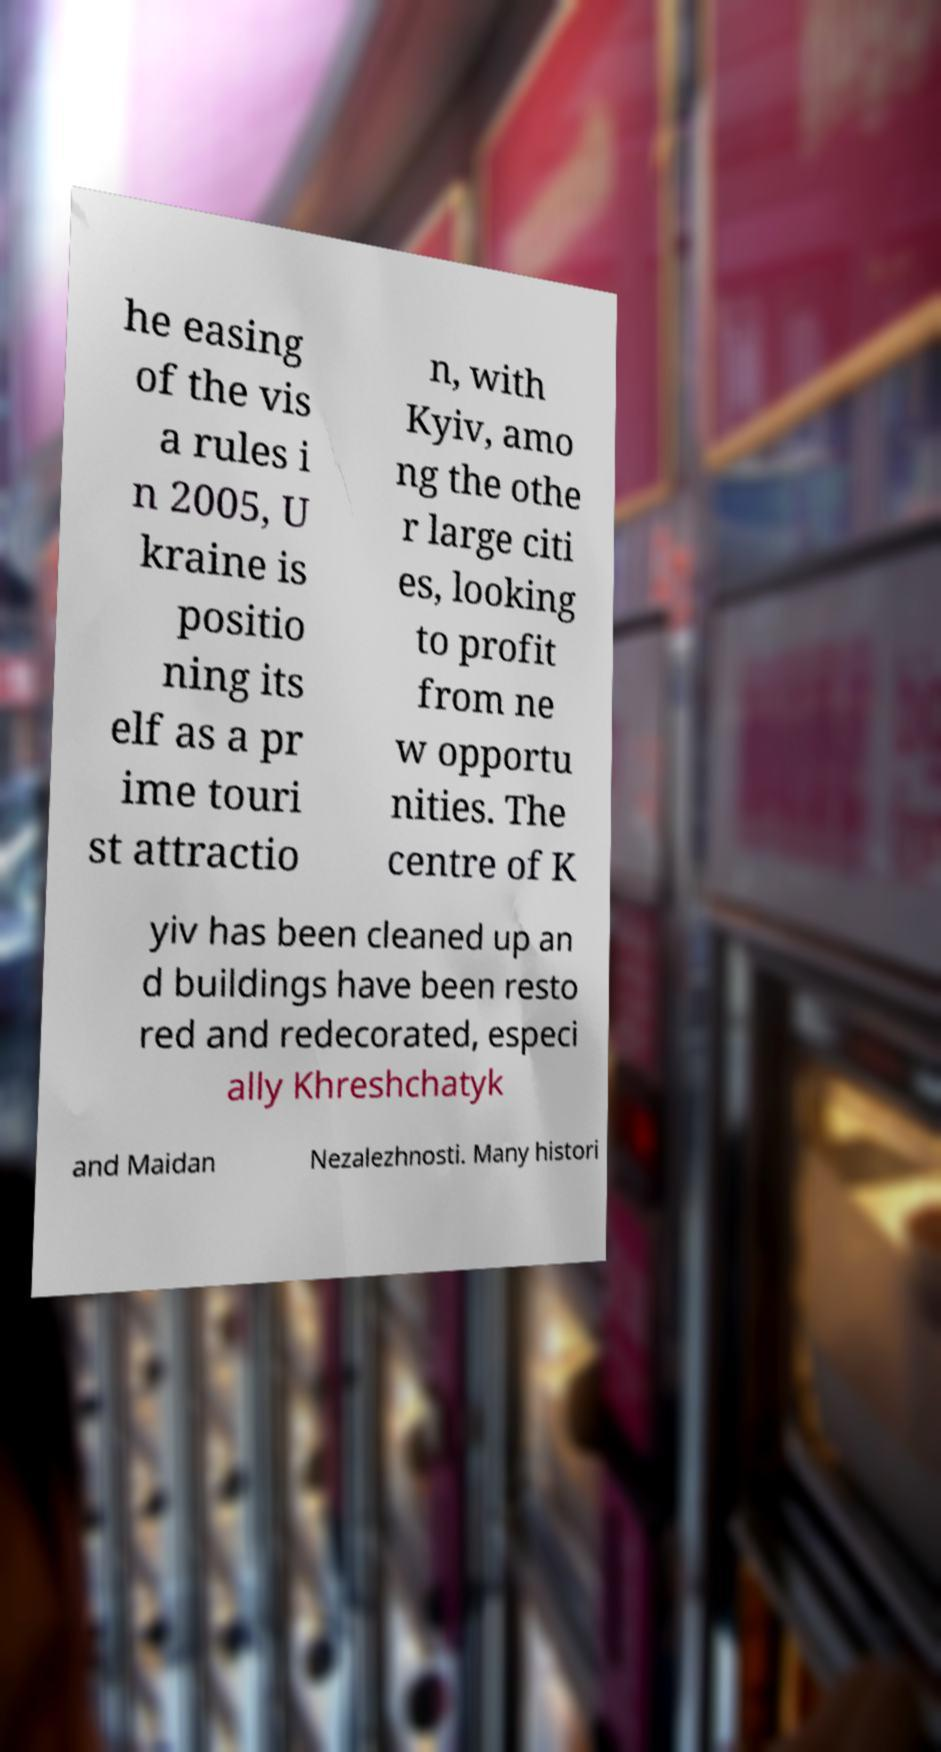Please identify and transcribe the text found in this image. he easing of the vis a rules i n 2005, U kraine is positio ning its elf as a pr ime touri st attractio n, with Kyiv, amo ng the othe r large citi es, looking to profit from ne w opportu nities. The centre of K yiv has been cleaned up an d buildings have been resto red and redecorated, especi ally Khreshchatyk and Maidan Nezalezhnosti. Many histori 